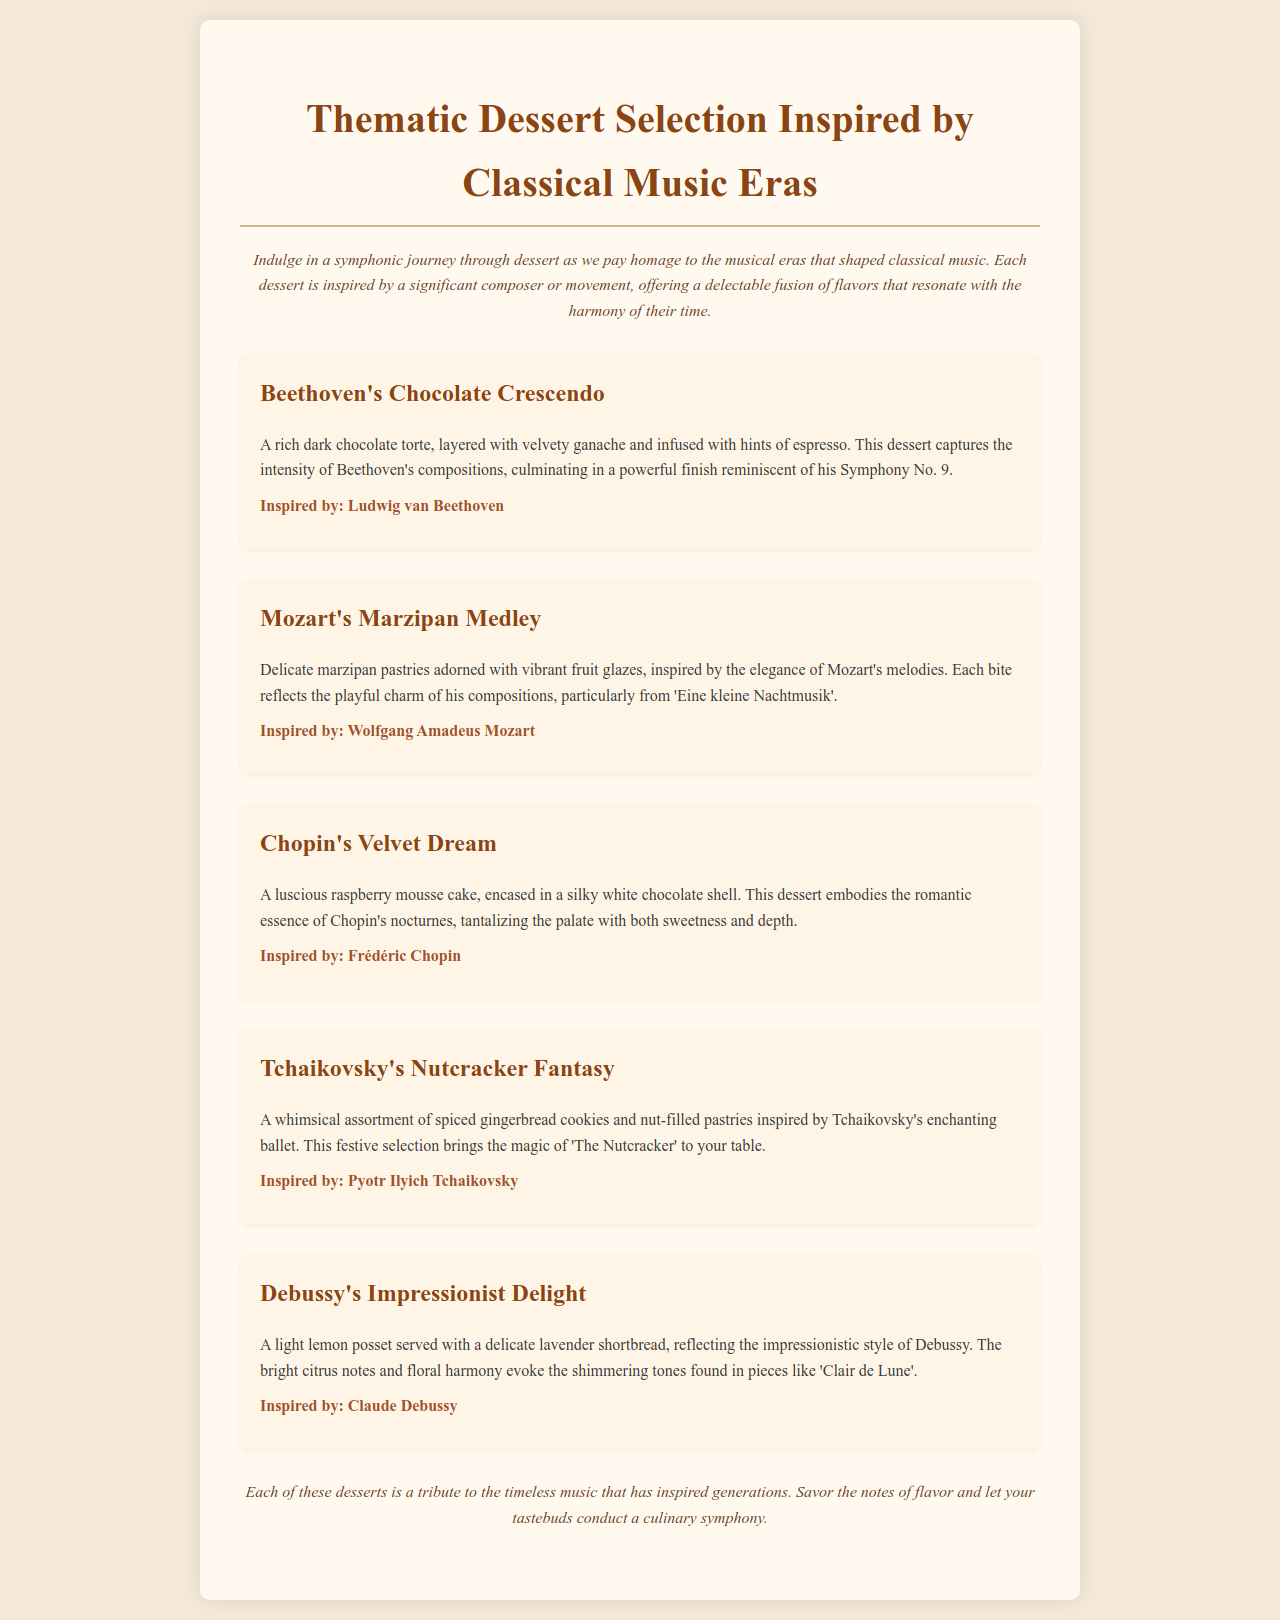What is the title of the dessert inspired by Beethoven? The dessert names are listed in the document, with "Beethoven's Chocolate Crescendo" being the title inspired by Beethoven.
Answer: Beethoven's Chocolate Crescendo What type of dessert is "Chopin's Velvet Dream"? Each dessert is described in the document, and "Chopin's Velvet Dream" is identified as a raspberry mousse cake.
Answer: Raspberry mousse cake Which composer inspired the "Nutcracker Fantasy"? The document clearly states that "Tchaikovsky's Nutcracker Fantasy" is inspired by Pyotr Ilyich Tchaikovsky.
Answer: Pyotr Ilyich Tchaikovsky What fruit flavor is featured in Debussy's dessert? The dessert description indicates that the flavor is light lemon, reflecting the characteristics of Debussy's style.
Answer: Lemon How many desserts are listed in the menu? By counting the individual dessert sections in the document, we find there are five desserts listed.
Answer: Five 